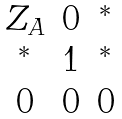<formula> <loc_0><loc_0><loc_500><loc_500>\begin{matrix} Z _ { A } & 0 & ^ { * } \\ ^ { * } & 1 & ^ { * } \\ 0 & 0 & 0 \end{matrix}</formula> 